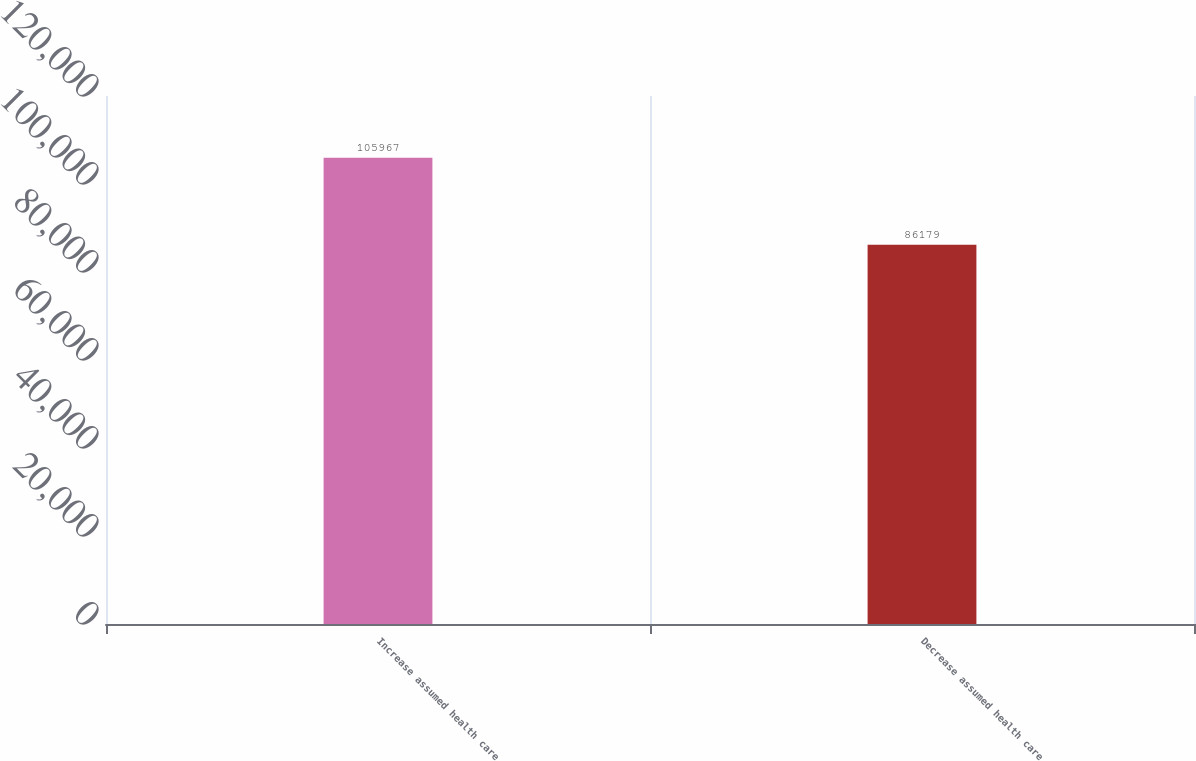Convert chart. <chart><loc_0><loc_0><loc_500><loc_500><bar_chart><fcel>Increase assumed health care<fcel>Decrease assumed health care<nl><fcel>105967<fcel>86179<nl></chart> 